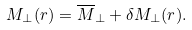<formula> <loc_0><loc_0><loc_500><loc_500>M _ { \perp } ( { r } ) = \overline { M } _ { \perp } + \delta M _ { \perp } ( { r } ) .</formula> 